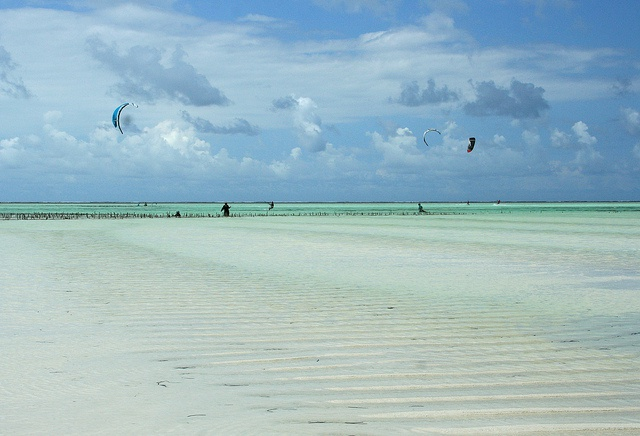Describe the objects in this image and their specific colors. I can see kite in lightblue, black, and teal tones, kite in lightblue, black, gray, purple, and darkgray tones, people in lightblue, black, gray, turquoise, and teal tones, kite in lightblue, gray, and blue tones, and people in lightblue, gray, black, and teal tones in this image. 